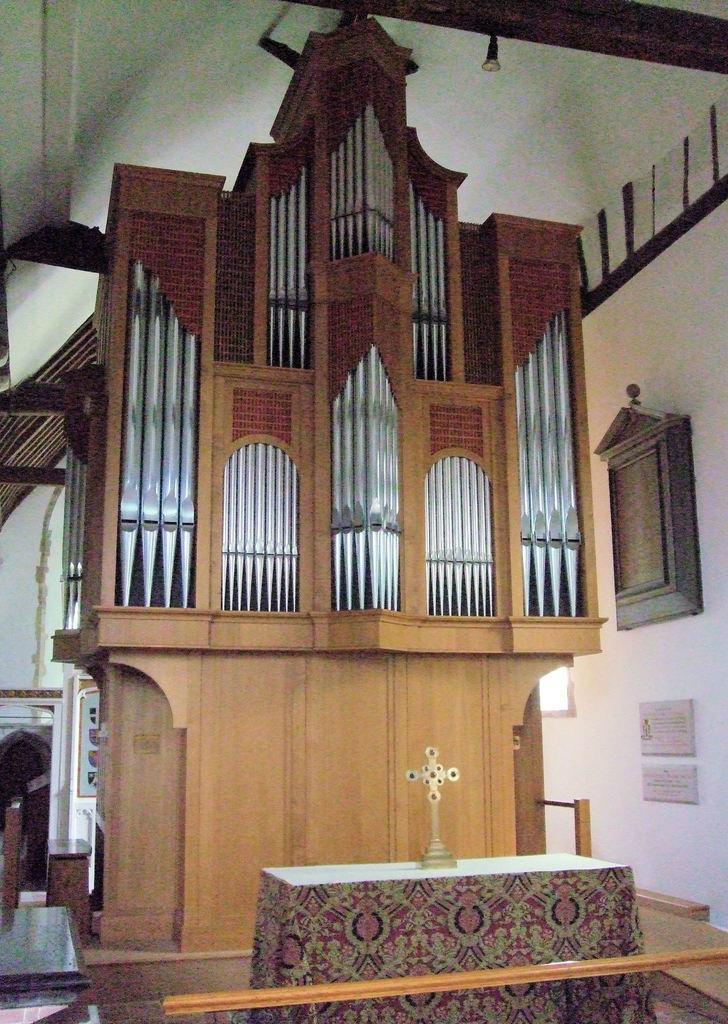Could you give a brief overview of what you see in this image? At the bottom of the image, we can see a table with cloth and holy cross object. Here we can see a railing. In the background, we can see wooden architectural, wall, boards and few things. 